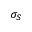<formula> <loc_0><loc_0><loc_500><loc_500>\sigma _ { S }</formula> 